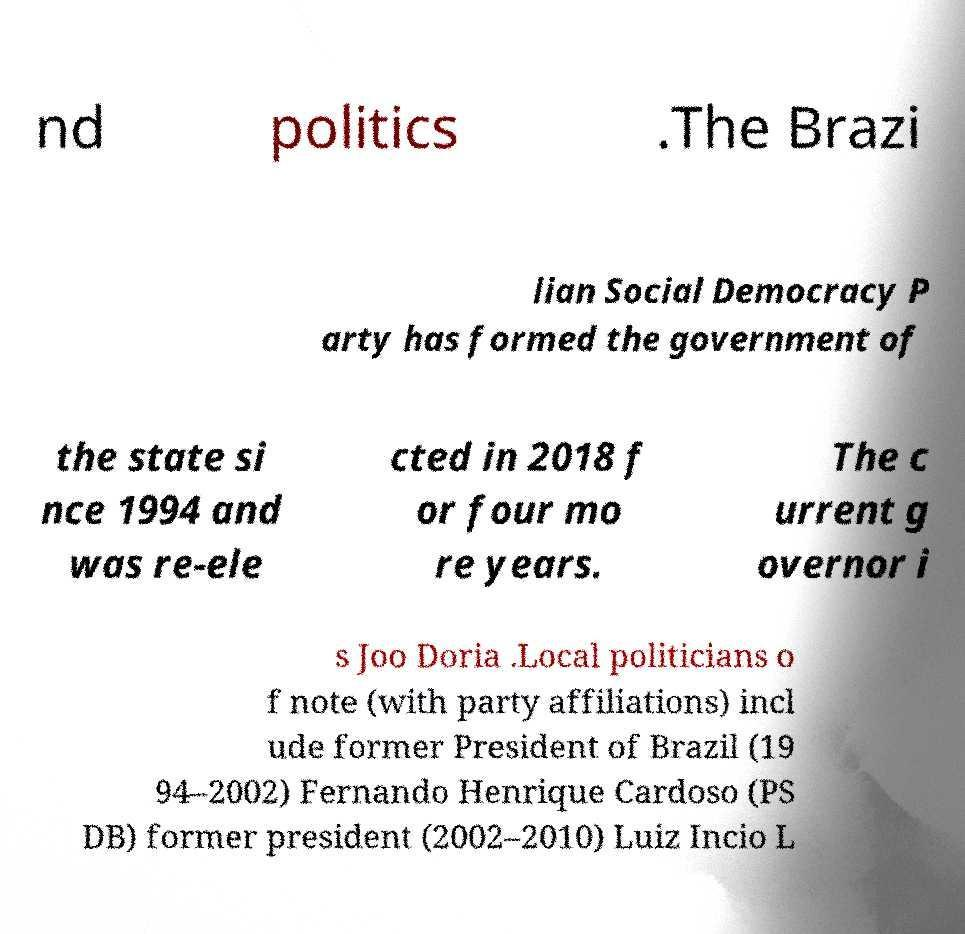Please read and relay the text visible in this image. What does it say? nd politics .The Brazi lian Social Democracy P arty has formed the government of the state si nce 1994 and was re-ele cted in 2018 f or four mo re years. The c urrent g overnor i s Joo Doria .Local politicians o f note (with party affiliations) incl ude former President of Brazil (19 94–2002) Fernando Henrique Cardoso (PS DB) former president (2002–2010) Luiz Incio L 